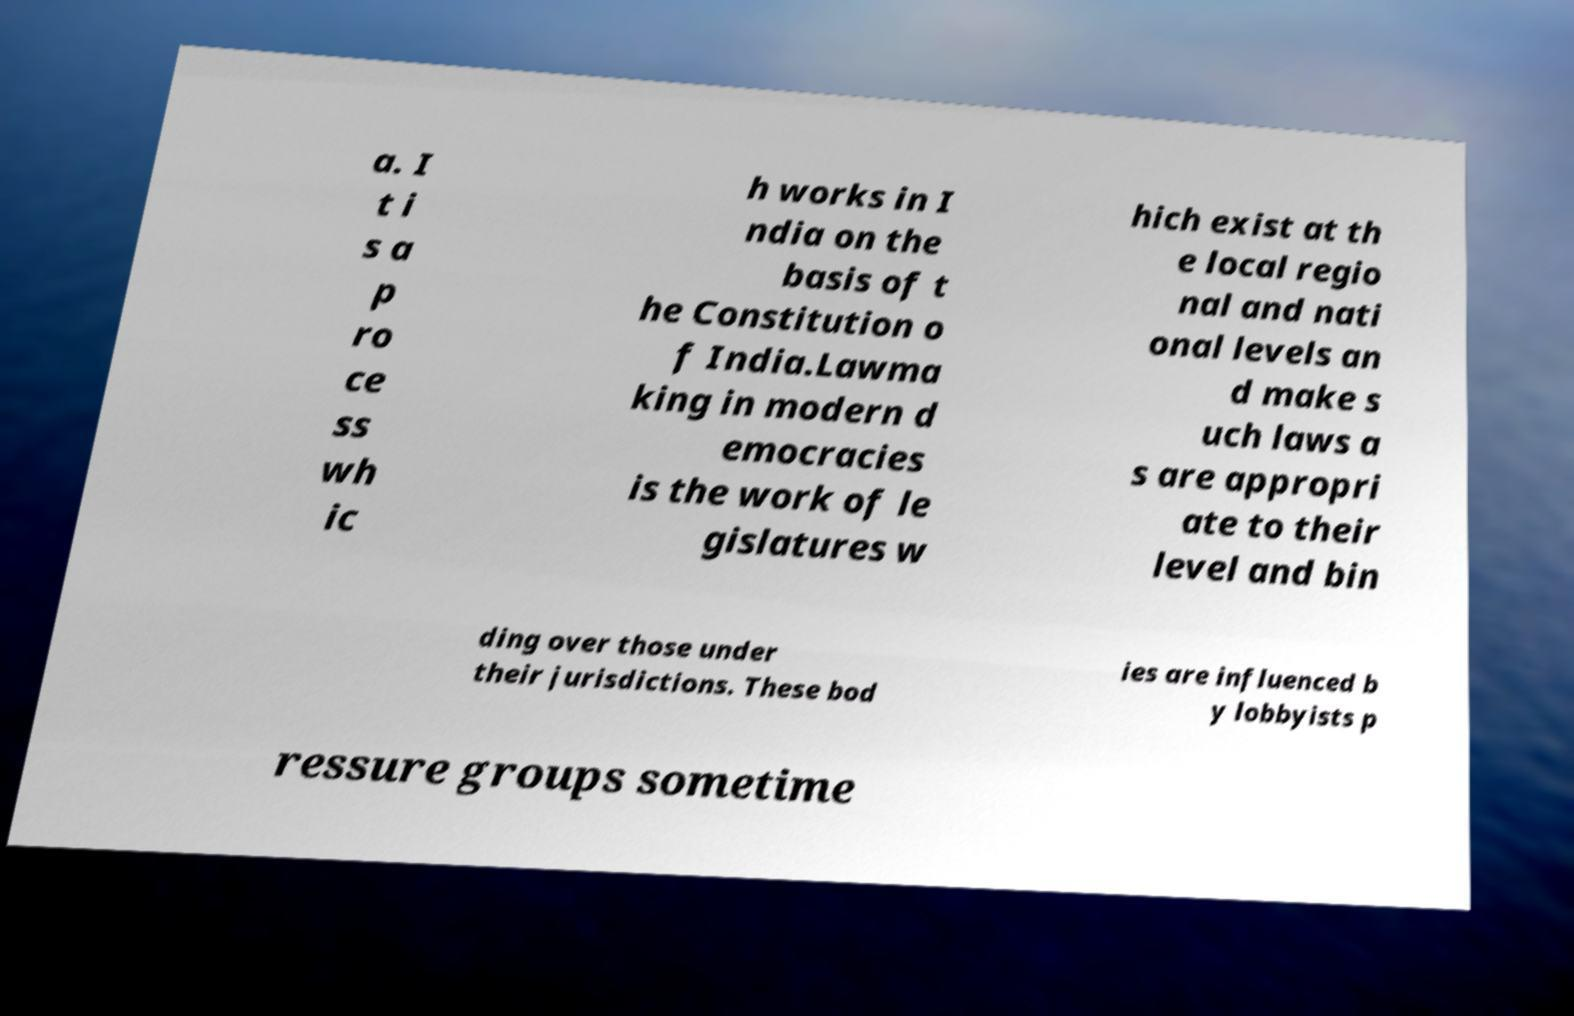There's text embedded in this image that I need extracted. Can you transcribe it verbatim? a. I t i s a p ro ce ss wh ic h works in I ndia on the basis of t he Constitution o f India.Lawma king in modern d emocracies is the work of le gislatures w hich exist at th e local regio nal and nati onal levels an d make s uch laws a s are appropri ate to their level and bin ding over those under their jurisdictions. These bod ies are influenced b y lobbyists p ressure groups sometime 